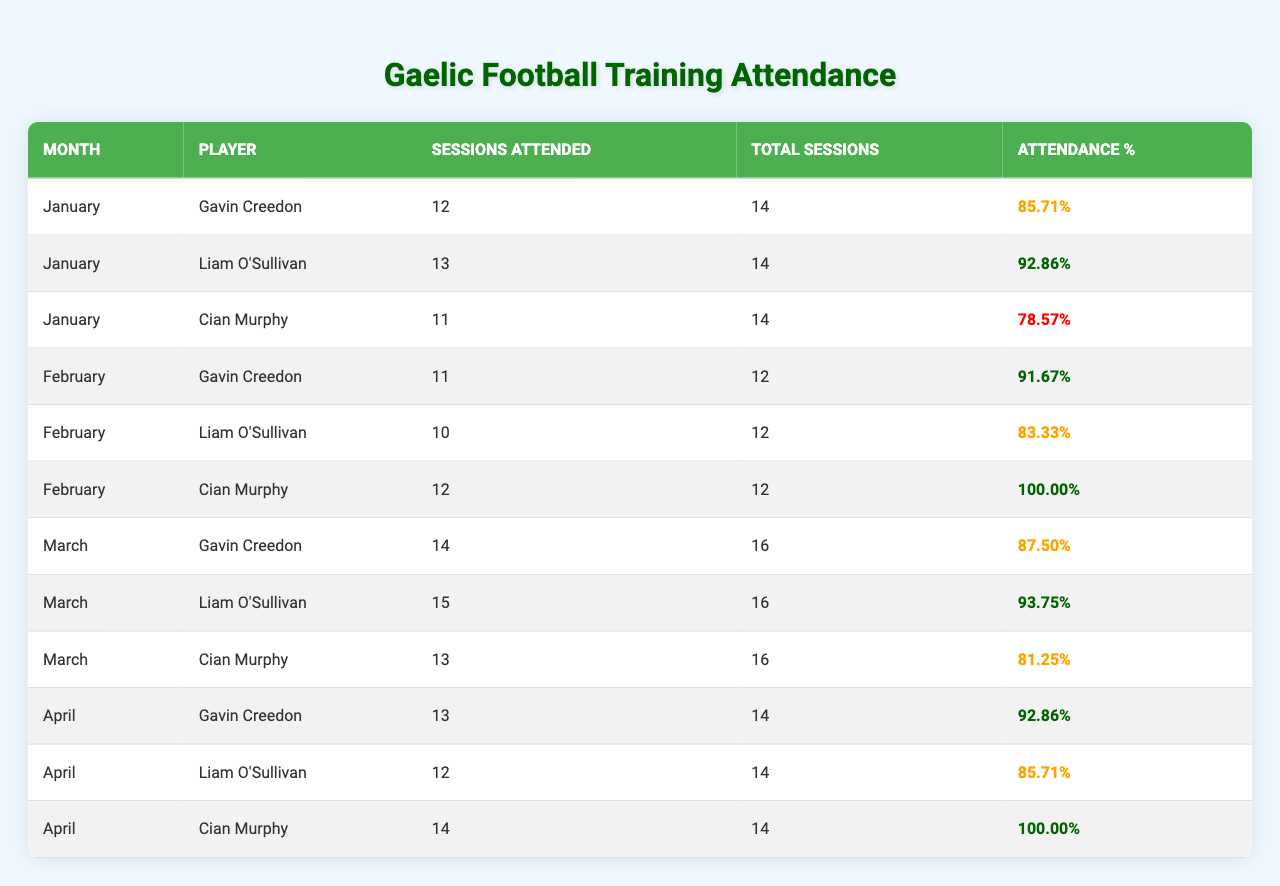What's Gavin Creedon's attendance percentage in February? In February, Gavin Creedon attended 11 out of 12 training sessions. To calculate his attendance percentage, we use the formula (Training Sessions Attended / Total Sessions Held) * 100, which gives us (11 / 12) * 100 = 91.67%
Answer: 91.67% Which month had the highest attendance percentage for Cian Murphy? In January, Cian Murphy had an attendance percentage of 78.57%, while in February he had 100%, and in March he had 81.25%. The highest attendance percentage is 100% in February.
Answer: February How many training sessions did Gavin attend in total from January to April? Gavin attended 12 in January, 11 in February, 14 in March, and 13 in April. The total is 12 + 11 + 14 + 13 = 50.
Answer: 50 Did Liam O'Sullivan have a higher attendance percentage than Gavin Creedon in any month? In January, Liam had 92.86% compared to Gavin's 85.71%, which is higher. In February, Gavin's 91.67% was higher than Liam's 83.33%. In March, Liam's 93.75% was higher than Gavin's 87.50%. In April, both had 92.86%, so yes, he had higher percentages in January and March.
Answer: Yes What is the average attendance percentage for Gavin Creedon over the four months? Gavin's attendance percentages are 85.71%, 91.67%, 87.50%, and 92.86%. To find the average: (85.71 + 91.67 + 87.50 + 92.86) / 4 = 89.49%.
Answer: 89.49% How many total training sessions were held in April, and what was the attendance percentage? In April, a total of 14 training sessions were held. Gavin attended 13 sessions, which gives him an attendance percentage of (13 / 14) * 100 = 92.86%.
Answer: 14 sessions, 92.86% Who had the best attendance percentage in March? In March, Gavin attended 14 out of 16 sessions (87.50%), Liam attended 15 out of 16 sessions (93.75%), and Cian attended 13 out of 16 sessions (81.25%). Liam had the best attendance percentage.
Answer: Liam O'Sullivan If we consider only the months with more than 10 sessions attended, which player had the highest average attendance percentage? Gavin attended 12, 11, 14, and 13 sessions across the months. His percentages are 85.71%, 91.67%, 87.50%, and 92.86%. Cian's qualifying months and percentages are 11 (78.57%), 12 (100%), and 13 (81.25%). The average for Gavin is 89.49% and for Cian is (100 + 81.25 + 78.57) / 3 = 86.94%. Gavin has the higher average.
Answer: Gavin Creedon How many sessions did Cian Murphy miss in January? In January, Cian attended 11 out of 14 sessions. To find out how many he missed, we subtract attended from total: 14 - 11 = 3.
Answer: 3 sessions Which player's attendance was consistently above 90% for the months listed? Gavin had 85.71% in January, 91.67% in February, 87.50% in March, and 92.86% in April. This means he was not above 90% in January. However, Liam's attendance is 92.86% in January, 83.33% in February, 93.75% in March, and 85.71% in April. Therefore, no player had consistently above 90%.
Answer: None 